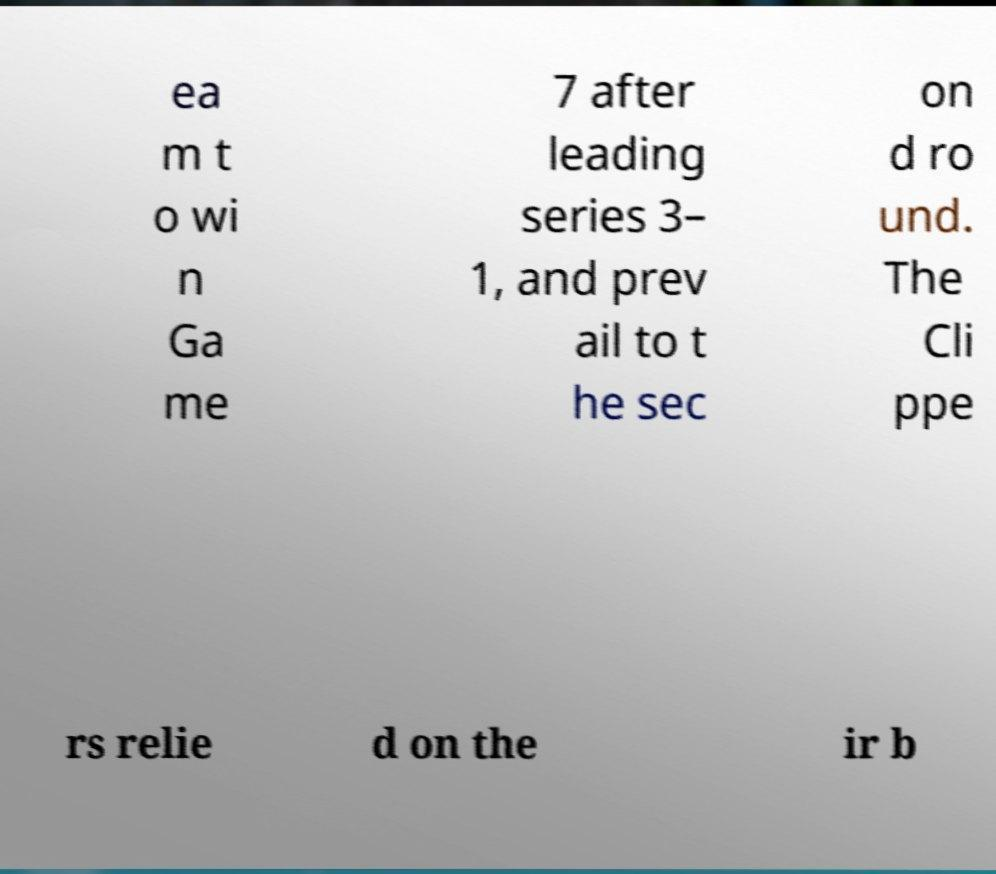Could you extract and type out the text from this image? ea m t o wi n Ga me 7 after leading series 3– 1, and prev ail to t he sec on d ro und. The Cli ppe rs relie d on the ir b 